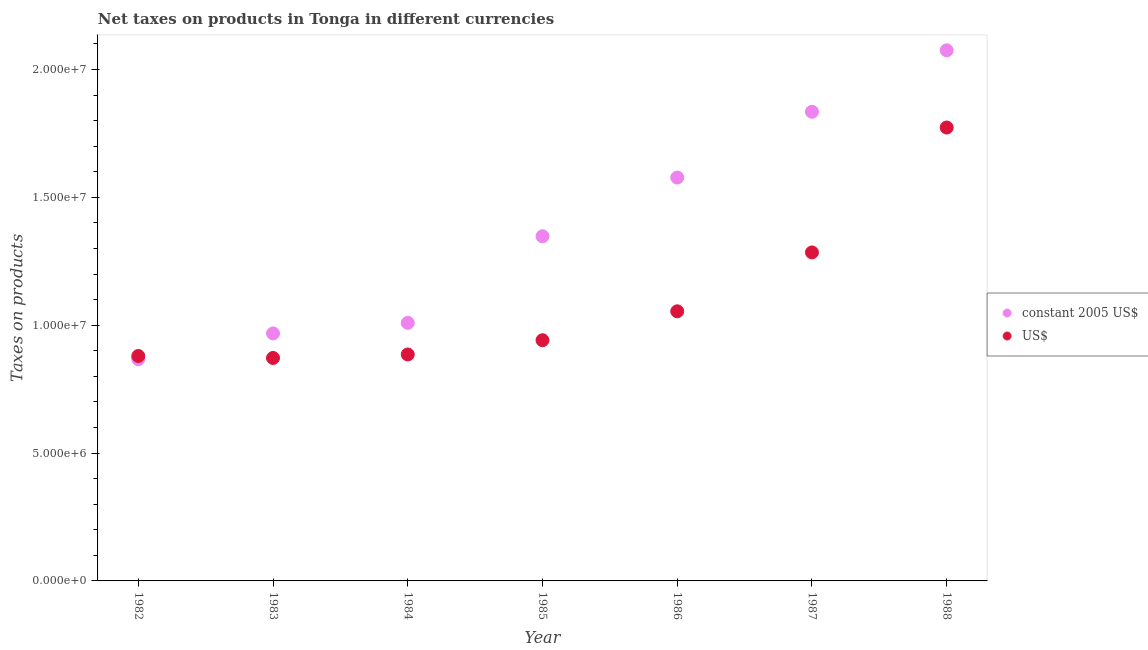How many different coloured dotlines are there?
Your answer should be very brief. 2. Is the number of dotlines equal to the number of legend labels?
Offer a terse response. Yes. What is the net taxes in us$ in 1986?
Your answer should be compact. 1.05e+07. Across all years, what is the maximum net taxes in constant 2005 us$?
Provide a short and direct response. 2.08e+07. Across all years, what is the minimum net taxes in constant 2005 us$?
Ensure brevity in your answer.  8.67e+06. In which year was the net taxes in us$ minimum?
Provide a short and direct response. 1983. What is the total net taxes in us$ in the graph?
Provide a short and direct response. 7.69e+07. What is the difference between the net taxes in constant 2005 us$ in 1984 and that in 1986?
Ensure brevity in your answer.  -5.68e+06. What is the difference between the net taxes in constant 2005 us$ in 1982 and the net taxes in us$ in 1984?
Provide a succinct answer. -1.83e+05. What is the average net taxes in us$ per year?
Offer a terse response. 1.10e+07. In the year 1988, what is the difference between the net taxes in us$ and net taxes in constant 2005 us$?
Make the answer very short. -3.02e+06. What is the ratio of the net taxes in constant 2005 us$ in 1984 to that in 1986?
Offer a very short reply. 0.64. Is the net taxes in constant 2005 us$ in 1982 less than that in 1985?
Ensure brevity in your answer.  Yes. Is the difference between the net taxes in us$ in 1983 and 1984 greater than the difference between the net taxes in constant 2005 us$ in 1983 and 1984?
Your response must be concise. Yes. What is the difference between the highest and the second highest net taxes in us$?
Your answer should be very brief. 4.88e+06. What is the difference between the highest and the lowest net taxes in constant 2005 us$?
Keep it short and to the point. 1.21e+07. Is the net taxes in constant 2005 us$ strictly less than the net taxes in us$ over the years?
Your answer should be very brief. No. How many dotlines are there?
Your response must be concise. 2. Does the graph contain any zero values?
Your answer should be very brief. No. How are the legend labels stacked?
Offer a very short reply. Vertical. What is the title of the graph?
Offer a very short reply. Net taxes on products in Tonga in different currencies. What is the label or title of the X-axis?
Offer a very short reply. Year. What is the label or title of the Y-axis?
Your response must be concise. Taxes on products. What is the Taxes on products of constant 2005 US$ in 1982?
Your answer should be compact. 8.67e+06. What is the Taxes on products in US$ in 1982?
Your answer should be compact. 8.80e+06. What is the Taxes on products in constant 2005 US$ in 1983?
Give a very brief answer. 9.68e+06. What is the Taxes on products of US$ in 1983?
Offer a terse response. 8.72e+06. What is the Taxes on products in constant 2005 US$ in 1984?
Give a very brief answer. 1.01e+07. What is the Taxes on products of US$ in 1984?
Offer a terse response. 8.86e+06. What is the Taxes on products of constant 2005 US$ in 1985?
Your answer should be very brief. 1.35e+07. What is the Taxes on products in US$ in 1985?
Keep it short and to the point. 9.41e+06. What is the Taxes on products in constant 2005 US$ in 1986?
Make the answer very short. 1.58e+07. What is the Taxes on products of US$ in 1986?
Give a very brief answer. 1.05e+07. What is the Taxes on products of constant 2005 US$ in 1987?
Provide a succinct answer. 1.83e+07. What is the Taxes on products of US$ in 1987?
Your answer should be very brief. 1.28e+07. What is the Taxes on products in constant 2005 US$ in 1988?
Your answer should be compact. 2.08e+07. What is the Taxes on products of US$ in 1988?
Keep it short and to the point. 1.77e+07. Across all years, what is the maximum Taxes on products of constant 2005 US$?
Give a very brief answer. 2.08e+07. Across all years, what is the maximum Taxes on products of US$?
Keep it short and to the point. 1.77e+07. Across all years, what is the minimum Taxes on products of constant 2005 US$?
Your answer should be compact. 8.67e+06. Across all years, what is the minimum Taxes on products of US$?
Offer a very short reply. 8.72e+06. What is the total Taxes on products in constant 2005 US$ in the graph?
Your answer should be compact. 9.68e+07. What is the total Taxes on products in US$ in the graph?
Provide a succinct answer. 7.69e+07. What is the difference between the Taxes on products of constant 2005 US$ in 1982 and that in 1983?
Offer a terse response. -1.00e+06. What is the difference between the Taxes on products of US$ in 1982 and that in 1983?
Make the answer very short. 7.82e+04. What is the difference between the Taxes on products of constant 2005 US$ in 1982 and that in 1984?
Your answer should be compact. -1.42e+06. What is the difference between the Taxes on products in US$ in 1982 and that in 1984?
Provide a short and direct response. -5.93e+04. What is the difference between the Taxes on products of constant 2005 US$ in 1982 and that in 1985?
Offer a very short reply. -4.81e+06. What is the difference between the Taxes on products in US$ in 1982 and that in 1985?
Your answer should be compact. -6.16e+05. What is the difference between the Taxes on products in constant 2005 US$ in 1982 and that in 1986?
Provide a short and direct response. -7.10e+06. What is the difference between the Taxes on products in US$ in 1982 and that in 1986?
Your answer should be very brief. -1.75e+06. What is the difference between the Taxes on products in constant 2005 US$ in 1982 and that in 1987?
Make the answer very short. -9.68e+06. What is the difference between the Taxes on products in US$ in 1982 and that in 1987?
Your response must be concise. -4.05e+06. What is the difference between the Taxes on products in constant 2005 US$ in 1982 and that in 1988?
Offer a terse response. -1.21e+07. What is the difference between the Taxes on products of US$ in 1982 and that in 1988?
Give a very brief answer. -8.93e+06. What is the difference between the Taxes on products in constant 2005 US$ in 1983 and that in 1984?
Make the answer very short. -4.14e+05. What is the difference between the Taxes on products in US$ in 1983 and that in 1984?
Your answer should be compact. -1.38e+05. What is the difference between the Taxes on products in constant 2005 US$ in 1983 and that in 1985?
Your response must be concise. -3.80e+06. What is the difference between the Taxes on products of US$ in 1983 and that in 1985?
Your answer should be compact. -6.94e+05. What is the difference between the Taxes on products of constant 2005 US$ in 1983 and that in 1986?
Your answer should be compact. -6.10e+06. What is the difference between the Taxes on products of US$ in 1983 and that in 1986?
Offer a terse response. -1.82e+06. What is the difference between the Taxes on products of constant 2005 US$ in 1983 and that in 1987?
Offer a very short reply. -8.67e+06. What is the difference between the Taxes on products of US$ in 1983 and that in 1987?
Ensure brevity in your answer.  -4.13e+06. What is the difference between the Taxes on products in constant 2005 US$ in 1983 and that in 1988?
Your answer should be compact. -1.11e+07. What is the difference between the Taxes on products of US$ in 1983 and that in 1988?
Offer a very short reply. -9.01e+06. What is the difference between the Taxes on products of constant 2005 US$ in 1984 and that in 1985?
Your response must be concise. -3.39e+06. What is the difference between the Taxes on products of US$ in 1984 and that in 1985?
Keep it short and to the point. -5.57e+05. What is the difference between the Taxes on products of constant 2005 US$ in 1984 and that in 1986?
Your answer should be very brief. -5.68e+06. What is the difference between the Taxes on products of US$ in 1984 and that in 1986?
Give a very brief answer. -1.69e+06. What is the difference between the Taxes on products of constant 2005 US$ in 1984 and that in 1987?
Offer a very short reply. -8.26e+06. What is the difference between the Taxes on products in US$ in 1984 and that in 1987?
Provide a succinct answer. -3.99e+06. What is the difference between the Taxes on products in constant 2005 US$ in 1984 and that in 1988?
Ensure brevity in your answer.  -1.07e+07. What is the difference between the Taxes on products in US$ in 1984 and that in 1988?
Keep it short and to the point. -8.87e+06. What is the difference between the Taxes on products of constant 2005 US$ in 1985 and that in 1986?
Give a very brief answer. -2.30e+06. What is the difference between the Taxes on products in US$ in 1985 and that in 1986?
Make the answer very short. -1.13e+06. What is the difference between the Taxes on products of constant 2005 US$ in 1985 and that in 1987?
Your answer should be compact. -4.87e+06. What is the difference between the Taxes on products in US$ in 1985 and that in 1987?
Make the answer very short. -3.43e+06. What is the difference between the Taxes on products in constant 2005 US$ in 1985 and that in 1988?
Offer a very short reply. -7.27e+06. What is the difference between the Taxes on products in US$ in 1985 and that in 1988?
Your response must be concise. -8.32e+06. What is the difference between the Taxes on products of constant 2005 US$ in 1986 and that in 1987?
Offer a terse response. -2.57e+06. What is the difference between the Taxes on products in US$ in 1986 and that in 1987?
Give a very brief answer. -2.30e+06. What is the difference between the Taxes on products of constant 2005 US$ in 1986 and that in 1988?
Offer a terse response. -4.98e+06. What is the difference between the Taxes on products of US$ in 1986 and that in 1988?
Ensure brevity in your answer.  -7.19e+06. What is the difference between the Taxes on products of constant 2005 US$ in 1987 and that in 1988?
Provide a short and direct response. -2.40e+06. What is the difference between the Taxes on products in US$ in 1987 and that in 1988?
Your answer should be very brief. -4.88e+06. What is the difference between the Taxes on products in constant 2005 US$ in 1982 and the Taxes on products in US$ in 1983?
Your response must be concise. -4.58e+04. What is the difference between the Taxes on products in constant 2005 US$ in 1982 and the Taxes on products in US$ in 1984?
Keep it short and to the point. -1.83e+05. What is the difference between the Taxes on products of constant 2005 US$ in 1982 and the Taxes on products of US$ in 1985?
Keep it short and to the point. -7.40e+05. What is the difference between the Taxes on products of constant 2005 US$ in 1982 and the Taxes on products of US$ in 1986?
Your response must be concise. -1.87e+06. What is the difference between the Taxes on products in constant 2005 US$ in 1982 and the Taxes on products in US$ in 1987?
Keep it short and to the point. -4.17e+06. What is the difference between the Taxes on products of constant 2005 US$ in 1982 and the Taxes on products of US$ in 1988?
Offer a terse response. -9.06e+06. What is the difference between the Taxes on products in constant 2005 US$ in 1983 and the Taxes on products in US$ in 1984?
Make the answer very short. 8.22e+05. What is the difference between the Taxes on products of constant 2005 US$ in 1983 and the Taxes on products of US$ in 1985?
Provide a succinct answer. 2.65e+05. What is the difference between the Taxes on products of constant 2005 US$ in 1983 and the Taxes on products of US$ in 1986?
Provide a succinct answer. -8.66e+05. What is the difference between the Taxes on products of constant 2005 US$ in 1983 and the Taxes on products of US$ in 1987?
Provide a succinct answer. -3.17e+06. What is the difference between the Taxes on products of constant 2005 US$ in 1983 and the Taxes on products of US$ in 1988?
Provide a succinct answer. -8.05e+06. What is the difference between the Taxes on products in constant 2005 US$ in 1984 and the Taxes on products in US$ in 1985?
Your response must be concise. 6.79e+05. What is the difference between the Taxes on products of constant 2005 US$ in 1984 and the Taxes on products of US$ in 1986?
Provide a succinct answer. -4.52e+05. What is the difference between the Taxes on products in constant 2005 US$ in 1984 and the Taxes on products in US$ in 1987?
Provide a short and direct response. -2.75e+06. What is the difference between the Taxes on products in constant 2005 US$ in 1984 and the Taxes on products in US$ in 1988?
Offer a very short reply. -7.64e+06. What is the difference between the Taxes on products in constant 2005 US$ in 1985 and the Taxes on products in US$ in 1986?
Your response must be concise. 2.94e+06. What is the difference between the Taxes on products of constant 2005 US$ in 1985 and the Taxes on products of US$ in 1987?
Provide a succinct answer. 6.32e+05. What is the difference between the Taxes on products of constant 2005 US$ in 1985 and the Taxes on products of US$ in 1988?
Keep it short and to the point. -4.25e+06. What is the difference between the Taxes on products of constant 2005 US$ in 1986 and the Taxes on products of US$ in 1987?
Keep it short and to the point. 2.93e+06. What is the difference between the Taxes on products in constant 2005 US$ in 1986 and the Taxes on products in US$ in 1988?
Give a very brief answer. -1.96e+06. What is the difference between the Taxes on products of constant 2005 US$ in 1987 and the Taxes on products of US$ in 1988?
Ensure brevity in your answer.  6.17e+05. What is the average Taxes on products of constant 2005 US$ per year?
Provide a short and direct response. 1.38e+07. What is the average Taxes on products of US$ per year?
Your answer should be very brief. 1.10e+07. In the year 1982, what is the difference between the Taxes on products of constant 2005 US$ and Taxes on products of US$?
Your response must be concise. -1.24e+05. In the year 1983, what is the difference between the Taxes on products of constant 2005 US$ and Taxes on products of US$?
Your response must be concise. 9.59e+05. In the year 1984, what is the difference between the Taxes on products of constant 2005 US$ and Taxes on products of US$?
Offer a very short reply. 1.24e+06. In the year 1985, what is the difference between the Taxes on products in constant 2005 US$ and Taxes on products in US$?
Provide a short and direct response. 4.07e+06. In the year 1986, what is the difference between the Taxes on products in constant 2005 US$ and Taxes on products in US$?
Ensure brevity in your answer.  5.23e+06. In the year 1987, what is the difference between the Taxes on products of constant 2005 US$ and Taxes on products of US$?
Offer a terse response. 5.50e+06. In the year 1988, what is the difference between the Taxes on products in constant 2005 US$ and Taxes on products in US$?
Provide a succinct answer. 3.02e+06. What is the ratio of the Taxes on products in constant 2005 US$ in 1982 to that in 1983?
Make the answer very short. 0.9. What is the ratio of the Taxes on products of constant 2005 US$ in 1982 to that in 1984?
Provide a succinct answer. 0.86. What is the ratio of the Taxes on products of US$ in 1982 to that in 1984?
Give a very brief answer. 0.99. What is the ratio of the Taxes on products in constant 2005 US$ in 1982 to that in 1985?
Keep it short and to the point. 0.64. What is the ratio of the Taxes on products of US$ in 1982 to that in 1985?
Give a very brief answer. 0.93. What is the ratio of the Taxes on products of constant 2005 US$ in 1982 to that in 1986?
Provide a short and direct response. 0.55. What is the ratio of the Taxes on products of US$ in 1982 to that in 1986?
Offer a terse response. 0.83. What is the ratio of the Taxes on products of constant 2005 US$ in 1982 to that in 1987?
Your response must be concise. 0.47. What is the ratio of the Taxes on products in US$ in 1982 to that in 1987?
Make the answer very short. 0.68. What is the ratio of the Taxes on products in constant 2005 US$ in 1982 to that in 1988?
Your answer should be very brief. 0.42. What is the ratio of the Taxes on products in US$ in 1982 to that in 1988?
Ensure brevity in your answer.  0.5. What is the ratio of the Taxes on products in constant 2005 US$ in 1983 to that in 1984?
Your answer should be very brief. 0.96. What is the ratio of the Taxes on products in US$ in 1983 to that in 1984?
Keep it short and to the point. 0.98. What is the ratio of the Taxes on products of constant 2005 US$ in 1983 to that in 1985?
Ensure brevity in your answer.  0.72. What is the ratio of the Taxes on products of US$ in 1983 to that in 1985?
Keep it short and to the point. 0.93. What is the ratio of the Taxes on products of constant 2005 US$ in 1983 to that in 1986?
Ensure brevity in your answer.  0.61. What is the ratio of the Taxes on products in US$ in 1983 to that in 1986?
Make the answer very short. 0.83. What is the ratio of the Taxes on products of constant 2005 US$ in 1983 to that in 1987?
Your response must be concise. 0.53. What is the ratio of the Taxes on products of US$ in 1983 to that in 1987?
Your response must be concise. 0.68. What is the ratio of the Taxes on products of constant 2005 US$ in 1983 to that in 1988?
Ensure brevity in your answer.  0.47. What is the ratio of the Taxes on products in US$ in 1983 to that in 1988?
Keep it short and to the point. 0.49. What is the ratio of the Taxes on products of constant 2005 US$ in 1984 to that in 1985?
Offer a very short reply. 0.75. What is the ratio of the Taxes on products in US$ in 1984 to that in 1985?
Your answer should be compact. 0.94. What is the ratio of the Taxes on products in constant 2005 US$ in 1984 to that in 1986?
Keep it short and to the point. 0.64. What is the ratio of the Taxes on products of US$ in 1984 to that in 1986?
Ensure brevity in your answer.  0.84. What is the ratio of the Taxes on products of constant 2005 US$ in 1984 to that in 1987?
Make the answer very short. 0.55. What is the ratio of the Taxes on products of US$ in 1984 to that in 1987?
Your response must be concise. 0.69. What is the ratio of the Taxes on products of constant 2005 US$ in 1984 to that in 1988?
Your answer should be compact. 0.49. What is the ratio of the Taxes on products of US$ in 1984 to that in 1988?
Offer a very short reply. 0.5. What is the ratio of the Taxes on products of constant 2005 US$ in 1985 to that in 1986?
Keep it short and to the point. 0.85. What is the ratio of the Taxes on products in US$ in 1985 to that in 1986?
Your answer should be compact. 0.89. What is the ratio of the Taxes on products of constant 2005 US$ in 1985 to that in 1987?
Your response must be concise. 0.73. What is the ratio of the Taxes on products of US$ in 1985 to that in 1987?
Your answer should be compact. 0.73. What is the ratio of the Taxes on products of constant 2005 US$ in 1985 to that in 1988?
Provide a short and direct response. 0.65. What is the ratio of the Taxes on products of US$ in 1985 to that in 1988?
Provide a succinct answer. 0.53. What is the ratio of the Taxes on products of constant 2005 US$ in 1986 to that in 1987?
Your answer should be compact. 0.86. What is the ratio of the Taxes on products in US$ in 1986 to that in 1987?
Your answer should be very brief. 0.82. What is the ratio of the Taxes on products of constant 2005 US$ in 1986 to that in 1988?
Your response must be concise. 0.76. What is the ratio of the Taxes on products in US$ in 1986 to that in 1988?
Keep it short and to the point. 0.59. What is the ratio of the Taxes on products of constant 2005 US$ in 1987 to that in 1988?
Offer a very short reply. 0.88. What is the ratio of the Taxes on products in US$ in 1987 to that in 1988?
Your answer should be compact. 0.72. What is the difference between the highest and the second highest Taxes on products of constant 2005 US$?
Provide a succinct answer. 2.40e+06. What is the difference between the highest and the second highest Taxes on products in US$?
Provide a short and direct response. 4.88e+06. What is the difference between the highest and the lowest Taxes on products in constant 2005 US$?
Your response must be concise. 1.21e+07. What is the difference between the highest and the lowest Taxes on products of US$?
Your response must be concise. 9.01e+06. 